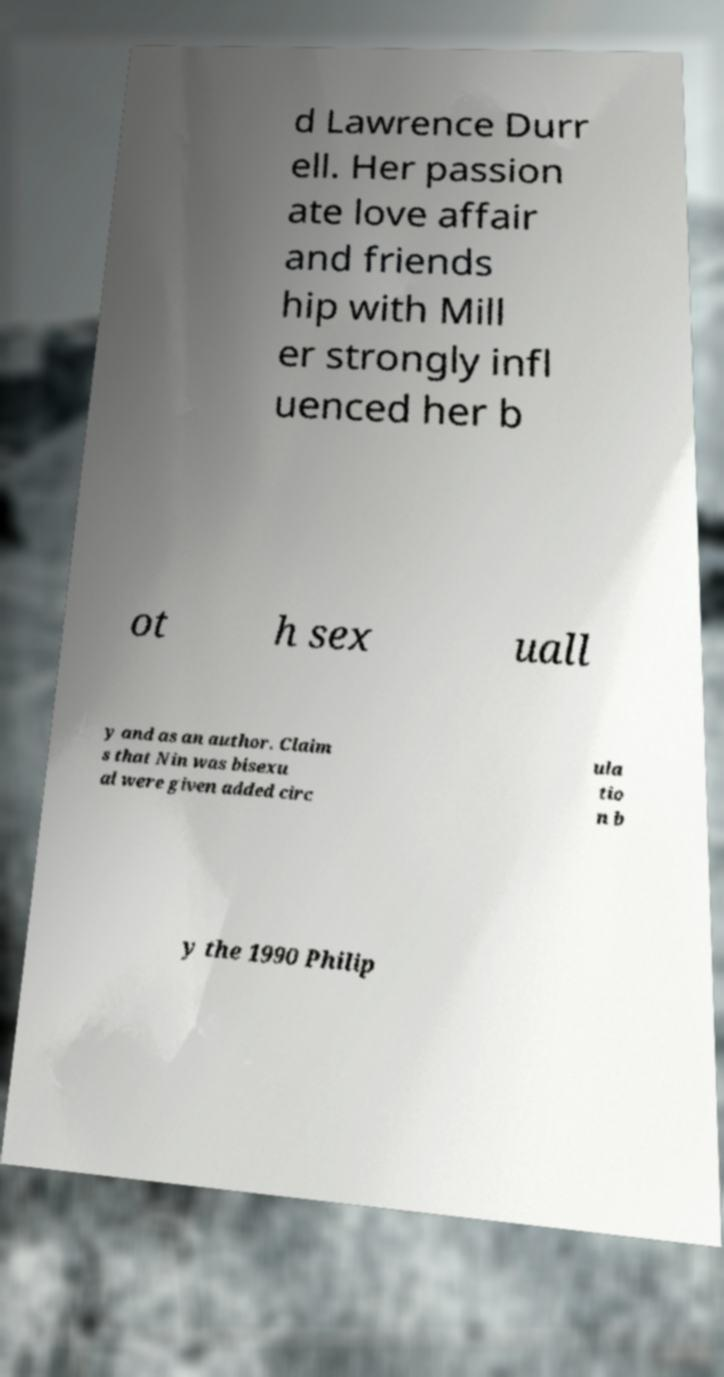Please identify and transcribe the text found in this image. d Lawrence Durr ell. Her passion ate love affair and friends hip with Mill er strongly infl uenced her b ot h sex uall y and as an author. Claim s that Nin was bisexu al were given added circ ula tio n b y the 1990 Philip 